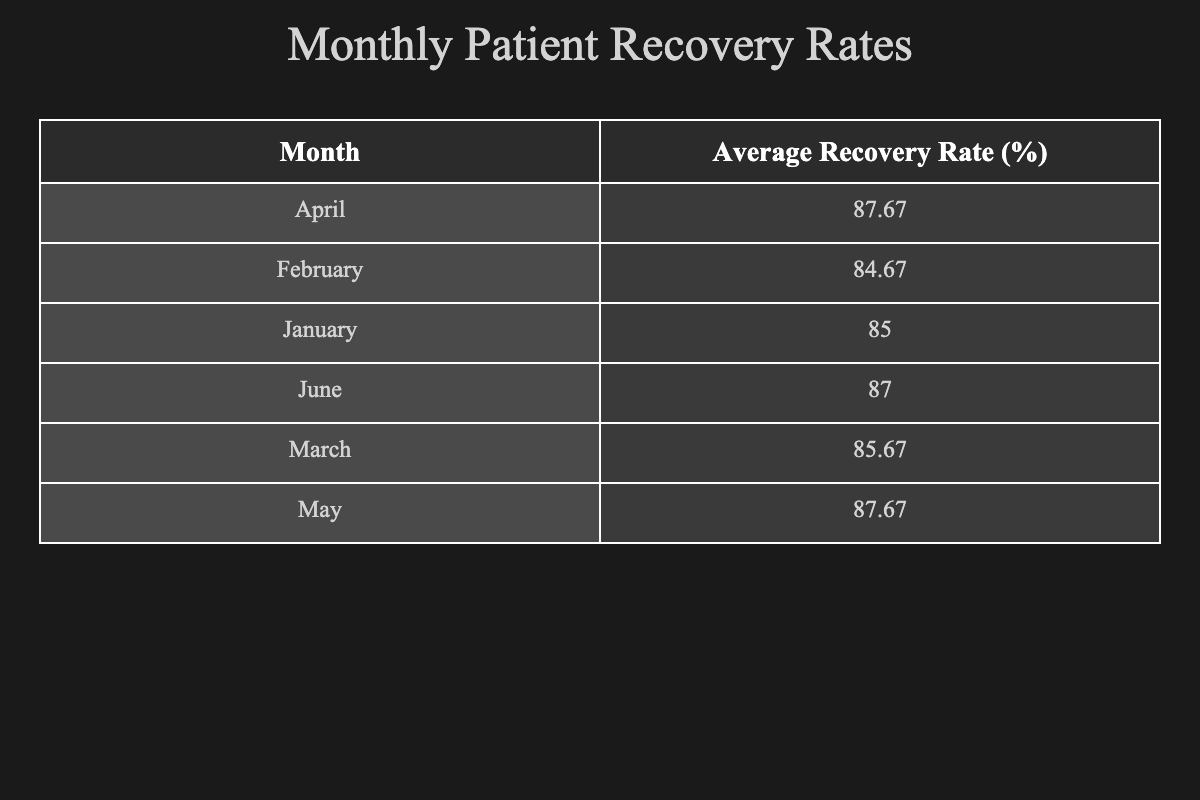What is the average recovery rate for February? To find the average recovery rate for February, look at the 'Recovery Rate (%)' for each patient in February: 87, 92, and 75. Summing these values gives 87 + 92 + 75 = 254. There are 3 patients in February, so we calculate the average by dividing the total by the number of patients: 254 / 3 = 84.67, rounded to 84.67.
Answer: 84.67 Which month had the highest average recovery rate? To determine which month had the highest average recovery rate, I’ll compare the average recovery rates for each month from the table: January's average is 85, February's is 84.67, March's is 85.67, April's is 87.67, and June's is 87.67. The highest value among these is 87.67, and it occurs in April and June.
Answer: April and June Is the recovery rate for hip replacement surgeries consistently high? We need to check the recovery rates for the hip replacement procedure listed in different months. For January, it is 90; for February, it is 92; for June, it is 93. Since all values are over 90, we can conclude that the recovery rate for hip replacement surgeries is consistently high across the months available in the data.
Answer: Yes What is the recovery rate difference between the highest and lowest recovery rates in March? In March, the recovery rates are 78 for open heart surgery, 88 for hernia repair, and 91 for gallbladder removal. The highest recovery rate is 91, and the lowest is 78. The difference is 91 - 78 = 13.
Answer: 13 Did any female patients have a recovery rate above 90%? We can review the recovery rates for female patients: in January, it's 90; in February, it's 87 and 75; in March, it's 88; in April, it's 86 and 95; in May, it's 84; and in June, it's 93. The only value that exceeds 90% is for carpal tunnel release in April with a rate of 95%. Therefore, the answer is yes, female patients did have a recovery rate above 90%.
Answer: Yes Which procedure type had the highest recovery rate in April? In April, the recovery rates for each procedure are: total knee replacement (86), bypass surgery (82), and carpal tunnel release (95). The highest recovery rate among these is 95, which corresponds to carpal tunnel release.
Answer: Carpal tunnel release How many total patients were accounted for in May? We look at the data for May, which lists three patients: rotator cuff surgery, prostate surgery, and thyroidectomy. Thus, the total number of patients in May is three.
Answer: 3 Compare the average recovery rates of males and females in January. In January, the recovery rates for males are: 85 (appendectomy) and 80 (coronary bypass), totaling 165 for 2 males. The average for males is 165 / 2 = 82.5. For females, there's only one patient at 90 (hip replacement), making her average 90. Comparing these averages shows that females have a higher average recovery rate than males in January.
Answer: Females are higher 